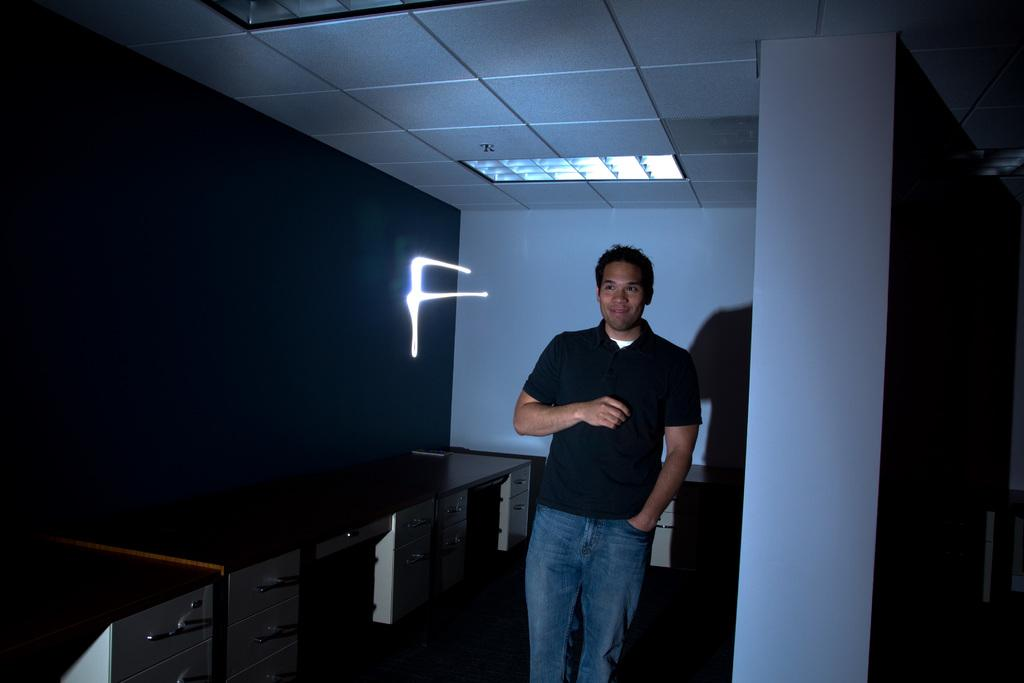What is the main subject of the image? There is a man standing in the middle of the image. What is the man wearing? The man is wearing a black t-shirt and jeans. Can you describe the lighting in the image? There is a light on the left side of the image. How does the man's feeling of happiness manifest itself in the image? There is no indication of the man's feelings in the image, so it cannot be determined from the picture. 